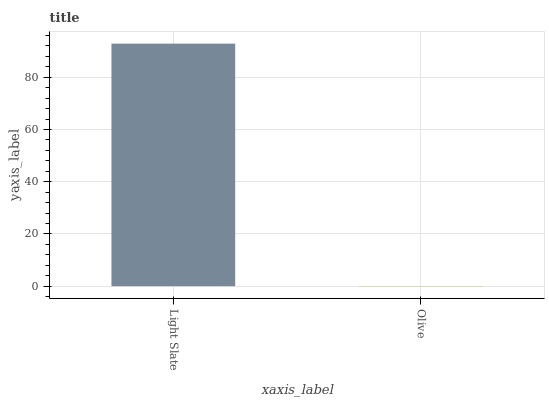Is Olive the maximum?
Answer yes or no. No. Is Light Slate greater than Olive?
Answer yes or no. Yes. Is Olive less than Light Slate?
Answer yes or no. Yes. Is Olive greater than Light Slate?
Answer yes or no. No. Is Light Slate less than Olive?
Answer yes or no. No. Is Light Slate the high median?
Answer yes or no. Yes. Is Olive the low median?
Answer yes or no. Yes. Is Olive the high median?
Answer yes or no. No. Is Light Slate the low median?
Answer yes or no. No. 